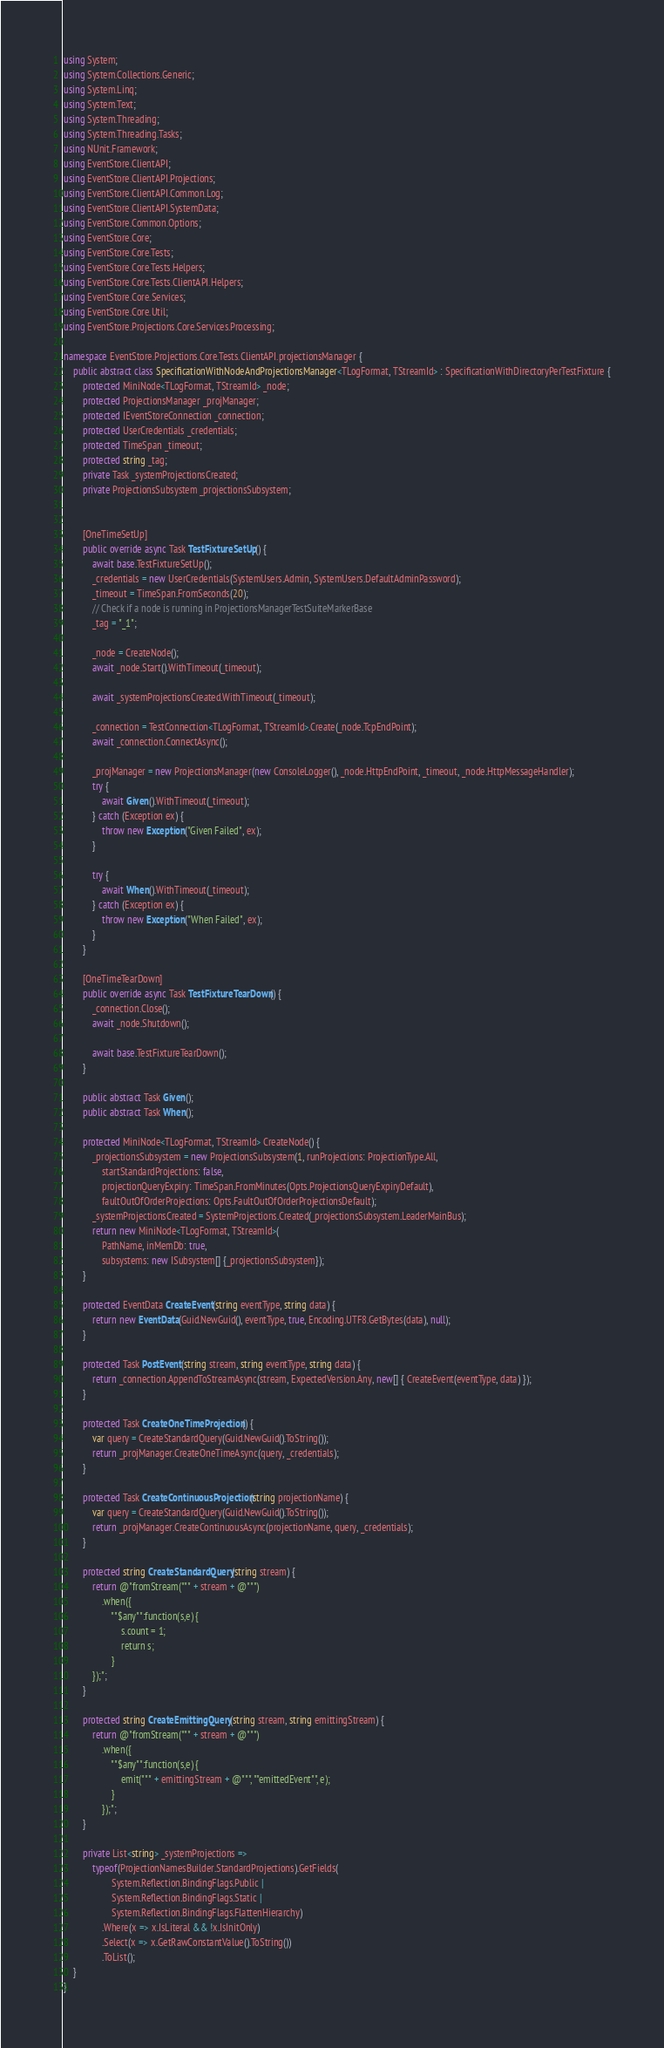Convert code to text. <code><loc_0><loc_0><loc_500><loc_500><_C#_>using System;
using System.Collections.Generic;
using System.Linq;
using System.Text;
using System.Threading;
using System.Threading.Tasks;
using NUnit.Framework;
using EventStore.ClientAPI;
using EventStore.ClientAPI.Projections;
using EventStore.ClientAPI.Common.Log;
using EventStore.ClientAPI.SystemData;
using EventStore.Common.Options;
using EventStore.Core;
using EventStore.Core.Tests;
using EventStore.Core.Tests.Helpers;
using EventStore.Core.Tests.ClientAPI.Helpers;
using EventStore.Core.Services;
using EventStore.Core.Util;
using EventStore.Projections.Core.Services.Processing;

namespace EventStore.Projections.Core.Tests.ClientAPI.projectionsManager {
	public abstract class SpecificationWithNodeAndProjectionsManager<TLogFormat, TStreamId> : SpecificationWithDirectoryPerTestFixture {
		protected MiniNode<TLogFormat, TStreamId> _node;
		protected ProjectionsManager _projManager;
		protected IEventStoreConnection _connection;
		protected UserCredentials _credentials;
		protected TimeSpan _timeout;
		protected string _tag;
		private Task _systemProjectionsCreated;
		private ProjectionsSubsystem _projectionsSubsystem;


		[OneTimeSetUp]
		public override async Task TestFixtureSetUp() {
			await base.TestFixtureSetUp();
			_credentials = new UserCredentials(SystemUsers.Admin, SystemUsers.DefaultAdminPassword);
			_timeout = TimeSpan.FromSeconds(20);
			// Check if a node is running in ProjectionsManagerTestSuiteMarkerBase
			_tag = "_1";

			_node = CreateNode();
			await _node.Start().WithTimeout(_timeout);

			await _systemProjectionsCreated.WithTimeout(_timeout);

			_connection = TestConnection<TLogFormat, TStreamId>.Create(_node.TcpEndPoint);
			await _connection.ConnectAsync();

			_projManager = new ProjectionsManager(new ConsoleLogger(), _node.HttpEndPoint, _timeout, _node.HttpMessageHandler);
			try {
				await Given().WithTimeout(_timeout);
			} catch (Exception ex) {
				throw new Exception("Given Failed", ex);
			}

			try {
				await When().WithTimeout(_timeout);
			} catch (Exception ex) {
				throw new Exception("When Failed", ex);
			}
		}

		[OneTimeTearDown]
		public override async Task TestFixtureTearDown() {
			_connection.Close();
			await _node.Shutdown();

			await base.TestFixtureTearDown();
		}

		public abstract Task Given();
		public abstract Task When();

		protected MiniNode<TLogFormat, TStreamId> CreateNode() {
			_projectionsSubsystem = new ProjectionsSubsystem(1, runProjections: ProjectionType.All,
				startStandardProjections: false,
				projectionQueryExpiry: TimeSpan.FromMinutes(Opts.ProjectionsQueryExpiryDefault),
				faultOutOfOrderProjections: Opts.FaultOutOfOrderProjectionsDefault);
			_systemProjectionsCreated = SystemProjections.Created(_projectionsSubsystem.LeaderMainBus);
			return new MiniNode<TLogFormat, TStreamId>(
				PathName, inMemDb: true,
				subsystems: new ISubsystem[] {_projectionsSubsystem});
		}

		protected EventData CreateEvent(string eventType, string data) {
			return new EventData(Guid.NewGuid(), eventType, true, Encoding.UTF8.GetBytes(data), null);
		}

		protected Task PostEvent(string stream, string eventType, string data) {
			return _connection.AppendToStreamAsync(stream, ExpectedVersion.Any, new[] { CreateEvent(eventType, data) });
		}

		protected Task CreateOneTimeProjection() {
			var query = CreateStandardQuery(Guid.NewGuid().ToString());
			return _projManager.CreateOneTimeAsync(query, _credentials);
		}

		protected Task CreateContinuousProjection(string projectionName) {
			var query = CreateStandardQuery(Guid.NewGuid().ToString());
			return _projManager.CreateContinuousAsync(projectionName, query, _credentials);
		}

		protected string CreateStandardQuery(string stream) {
			return @"fromStream(""" + stream + @""")
                .when({
                    ""$any"":function(s,e) {
                        s.count = 1;
                        return s;
                    }
            });";
		}

		protected string CreateEmittingQuery(string stream, string emittingStream) {
			return @"fromStream(""" + stream + @""")
                .when({
                    ""$any"":function(s,e) {
                        emit(""" + emittingStream + @""", ""emittedEvent"", e);
                    } 
                });";
		}
		
		private List<string> _systemProjections =>
			typeof(ProjectionNamesBuilder.StandardProjections).GetFields(
					System.Reflection.BindingFlags.Public |
					System.Reflection.BindingFlags.Static |
					System.Reflection.BindingFlags.FlattenHierarchy)
				.Where(x => x.IsLiteral && !x.IsInitOnly)
				.Select(x => x.GetRawConstantValue().ToString())
				.ToList();
	}
}
</code> 